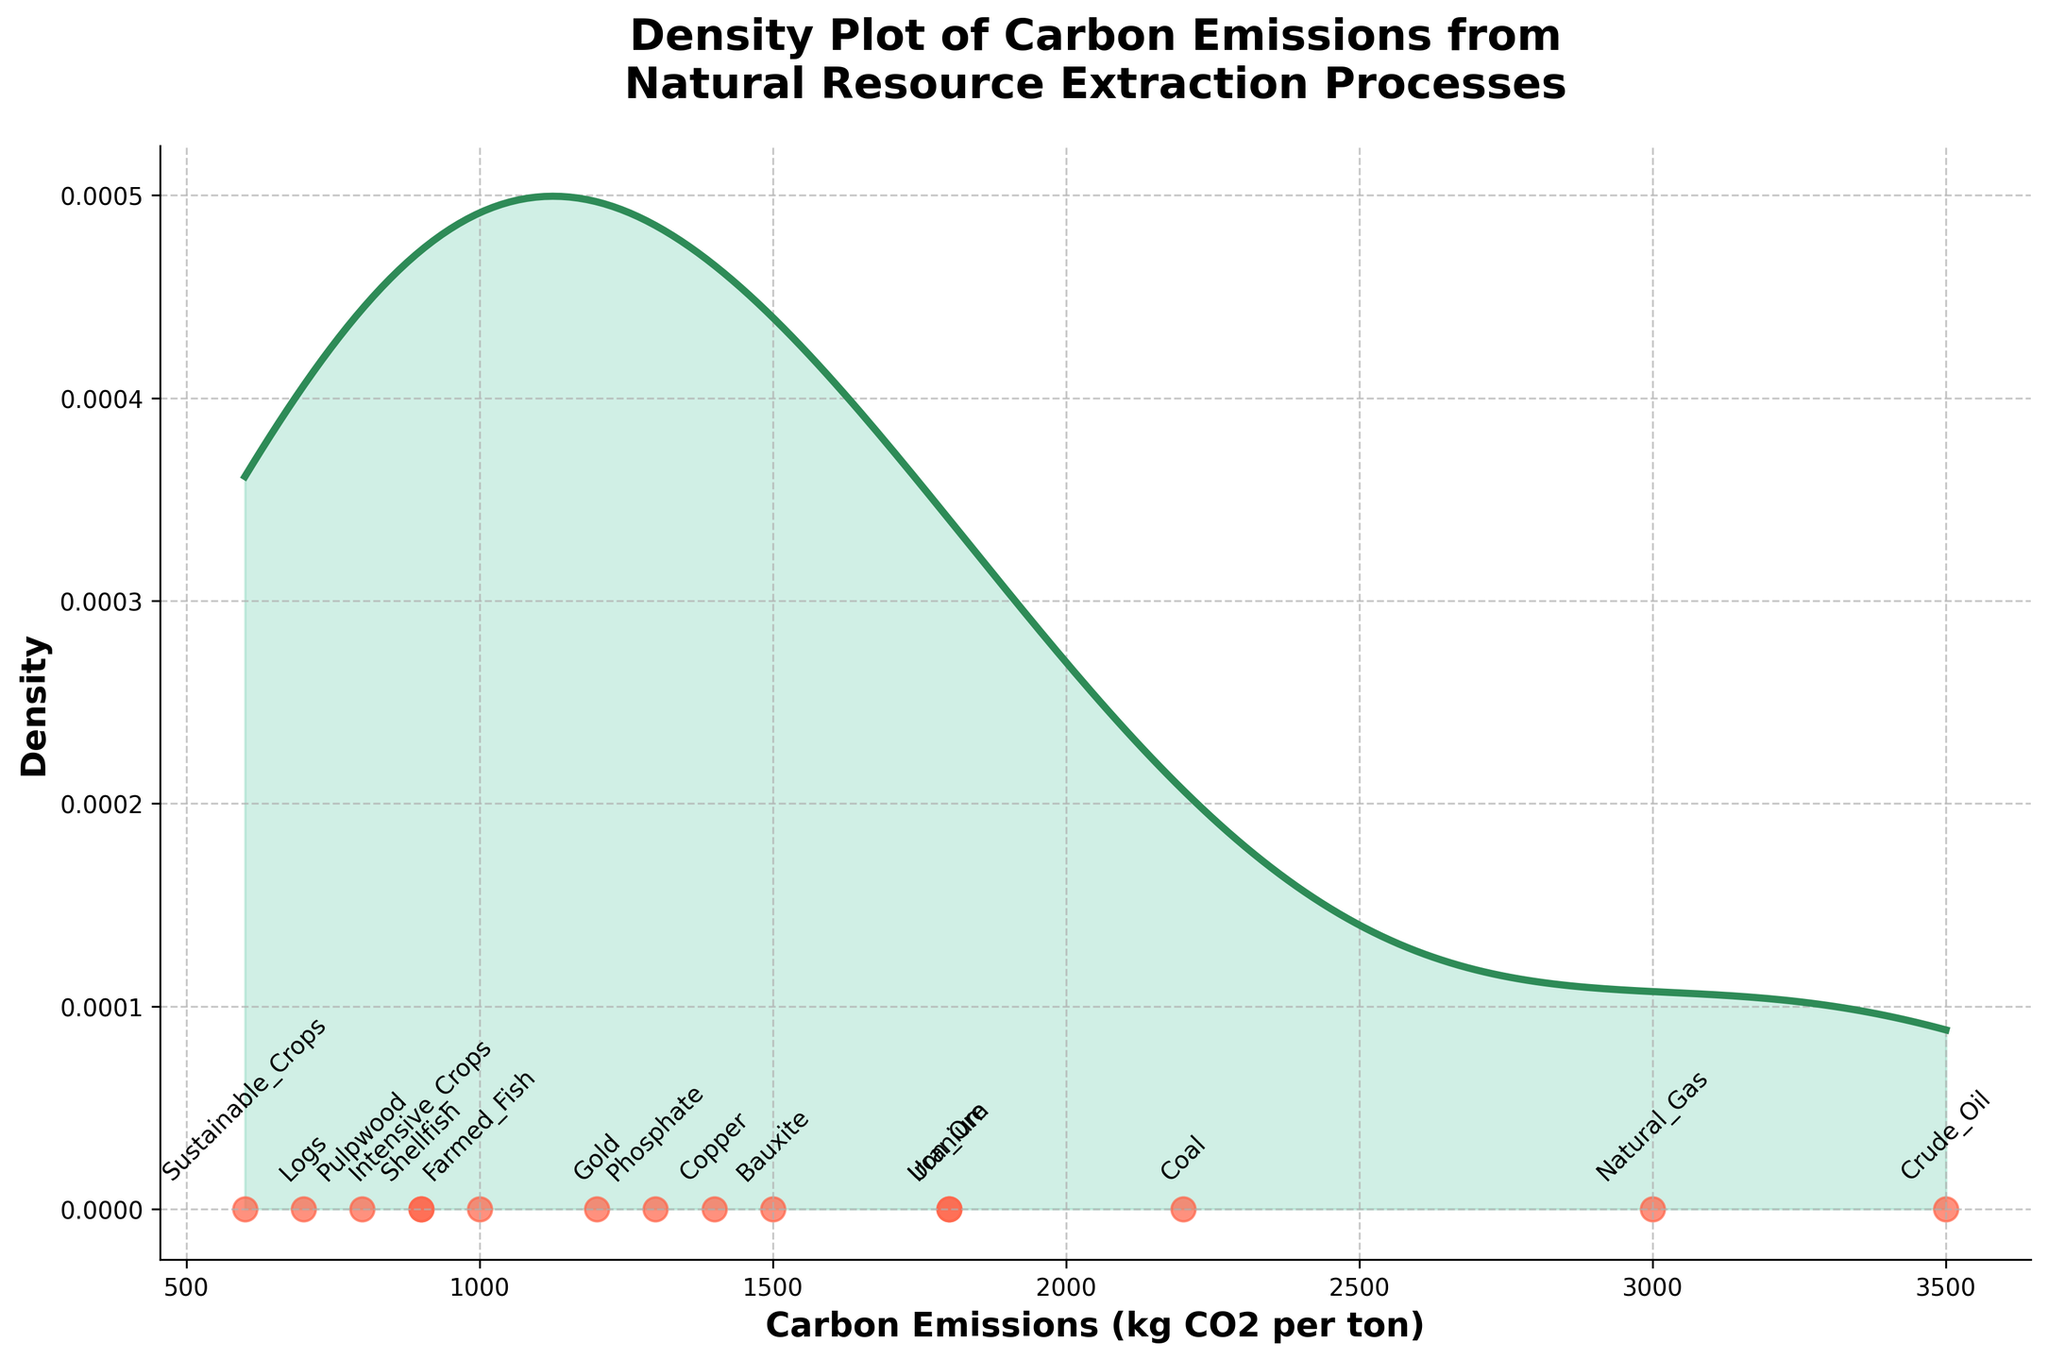How many different types of resource extraction processes are represented in the plot? The scatter points in the plot each represent a different type of resource extraction process. By counting the distinct scatter points, we can determine there are 14 types.
Answer: 14 Which resource has the highest carbon emissions? By examining the scatter points and their annotations, we can see that 'Crude_Oil' has the highest value on the x-axis at 3500 kg CO2 per ton.
Answer: Crude_Oil What is the range of carbon emissions values depicted in the plot? The x-axis ranges from 600 to 3500 kg CO2 per ton, based on the scatter point positions.
Answer: 600 to 3500 kg CO2 per ton Which type of resource extraction process generally has the lowest carbon emissions? The scatter points for the "Forestry" category are situated towards the lower end of the x-axis, indicating lower carbon emissions.
Answer: Forestry What is the approximate density value at 1800 kg CO2 per ton? From the density curve and x-axis, it appears that there is a peak in density around 1800 kg CO2 per ton. The y-axis value near this peak is approximately 0.00035.
Answer: 0.00035 How do the carbon emissions from 'Mining' processes compare with 'Drilling' processes? Mining processes such as Coal, Iron Ore, Bauxite, Gold, and Copper have generally lower emissions compared to Drilling processes like Crude Oil and Natural Gas, which have the highest values.
Answer: Mining processes are lower Which resource has the closest carbon emissions to 1000 kg CO2 per ton? Observing the scatter points and their annotations, we see that 'Farmed_Fish' has carbon emissions value closest to 1000 kg CO2 per ton.
Answer: Farmed_Fish What can you infer about the data point annotations and their corresponding positions on the plot? The annotations (resource names) are placed directly above their corresponding scatter points. Each scatter point's position on the x-axis indicates its carbon emissions value.
Answer: Annotations are above the points Are there any resource types that have exactly equal carbon emissions? From the scatter points and their annotations, no resource types are placed at exactly the same position on the x-axis, so there are no equal carbon emissions values.
Answer: No Which extraction category has the widest range of carbon emissions values? The "Mining" category has scatter points spread from 1200 to 2200 kg CO2 per ton, making it the category with the widest range of emissions values.
Answer: Mining 